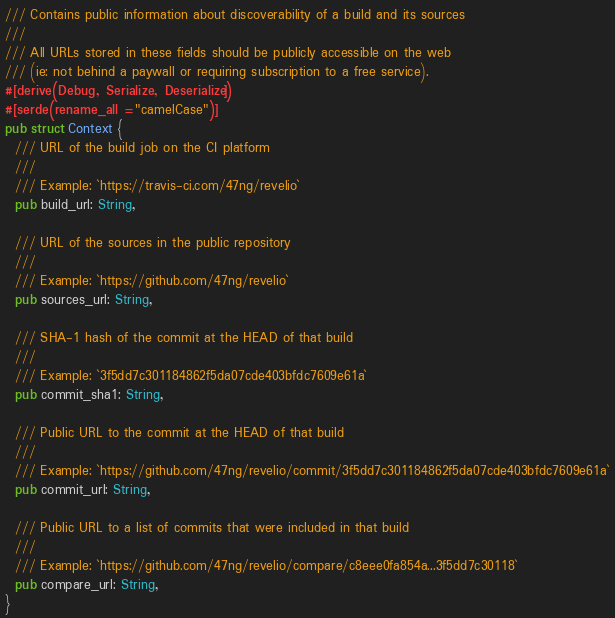Convert code to text. <code><loc_0><loc_0><loc_500><loc_500><_Rust_>/// Contains public information about discoverability of a build and its sources
///
/// All URLs stored in these fields should be publicly accessible on the web
/// (ie: not behind a paywall or requiring subscription to a free service).
#[derive(Debug, Serialize, Deserialize)]
#[serde(rename_all = "camelCase")]
pub struct Context {
  /// URL of the build job on the CI platform
  ///
  /// Example: `https://travis-ci.com/47ng/revelio`
  pub build_url: String,

  /// URL of the sources in the public repository
  ///
  /// Example: `https://github.com/47ng/revelio`
  pub sources_url: String,

  /// SHA-1 hash of the commit at the HEAD of that build
  ///
  /// Example: `3f5dd7c301184862f5da07cde403bfdc7609e61a`
  pub commit_sha1: String,

  /// Public URL to the commit at the HEAD of that build
  ///
  /// Example: `https://github.com/47ng/revelio/commit/3f5dd7c301184862f5da07cde403bfdc7609e61a`
  pub commit_url: String,

  /// Public URL to a list of commits that were included in that build
  ///
  /// Example: `https://github.com/47ng/revelio/compare/c8eee0fa854a...3f5dd7c30118`
  pub compare_url: String,
}
</code> 